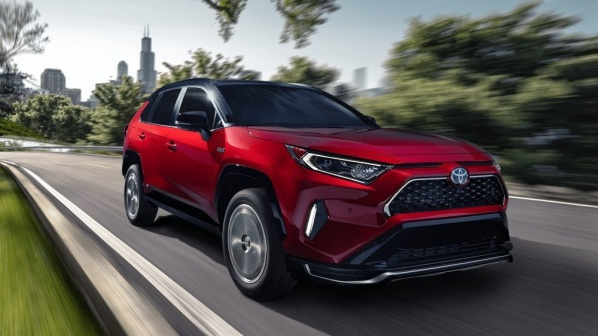What kind of weather conditions might the driver be experiencing based on this image? The image suggests clear and sunny weather conditions. The lighting indicates daytime with no signs of clouds or precipitation, and the road appears dry, contributing to a sense of a pleasant and ideal driving environment. 